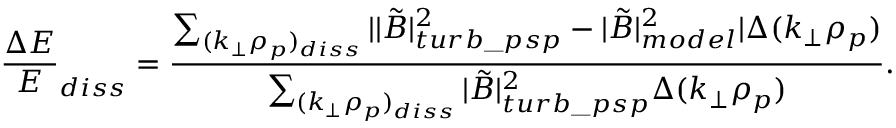Convert formula to latex. <formula><loc_0><loc_0><loc_500><loc_500>\frac { \Delta E } { E } _ { d i s s } = \frac { \sum _ { ( k _ { \perp } \rho _ { p } ) _ { d i s s } } | | \tilde { B } | _ { t u r b \_ p s p } ^ { 2 } - | \tilde { B } | _ { m o d e l } ^ { 2 } | \Delta ( k _ { \perp } \rho _ { p } ) } { \sum _ { ( k _ { \perp } \rho _ { p } ) _ { d i s s } } | \tilde { B } | _ { t u r b \_ p s p } ^ { 2 } \Delta ( k _ { \perp } \rho _ { p } ) } .</formula> 